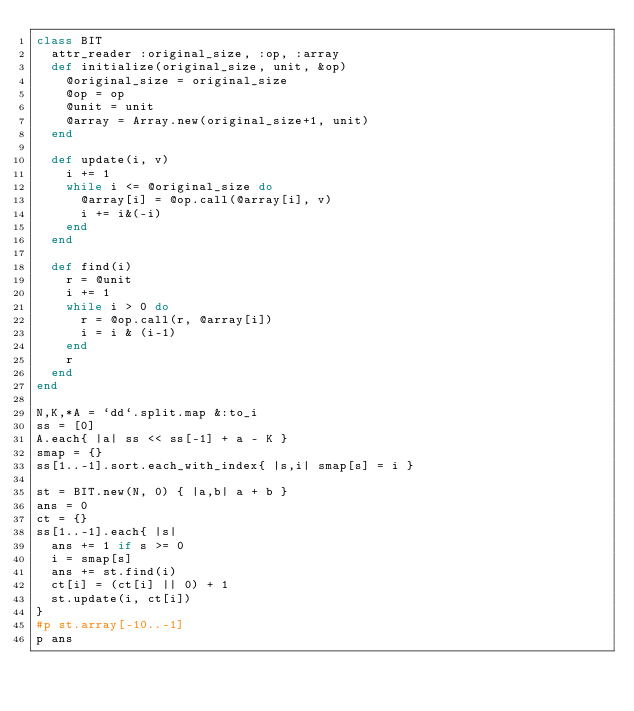<code> <loc_0><loc_0><loc_500><loc_500><_Ruby_>class BIT
  attr_reader :original_size, :op, :array
  def initialize(original_size, unit, &op)
    @original_size = original_size
    @op = op
    @unit = unit
    @array = Array.new(original_size+1, unit)
  end

  def update(i, v)
    i += 1
    while i <= @original_size do
      @array[i] = @op.call(@array[i], v)
      i += i&(-i)
    end
  end

  def find(i)
    r = @unit
    i += 1
    while i > 0 do
      r = @op.call(r, @array[i])
      i = i & (i-1)
    end
    r
  end
end

N,K,*A = `dd`.split.map &:to_i
ss = [0]
A.each{ |a| ss << ss[-1] + a - K }
smap = {}
ss[1..-1].sort.each_with_index{ |s,i| smap[s] = i }

st = BIT.new(N, 0) { |a,b| a + b }
ans = 0
ct = {}
ss[1..-1].each{ |s|
  ans += 1 if s >= 0
  i = smap[s]
  ans += st.find(i)
  ct[i] = (ct[i] || 0) + 1
  st.update(i, ct[i])
}
#p st.array[-10..-1]
p ans
</code> 